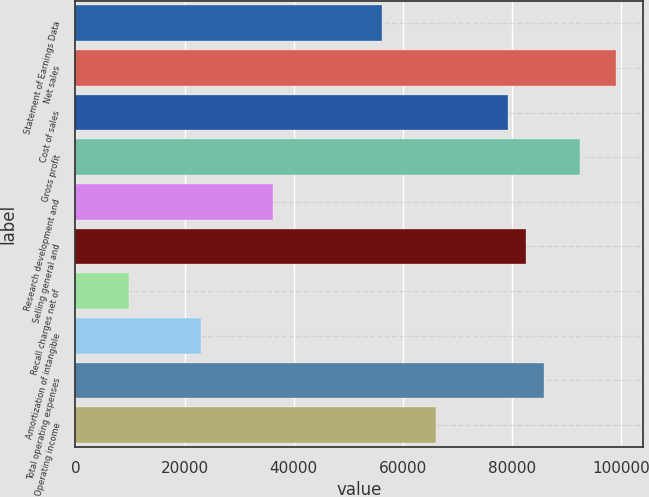Convert chart. <chart><loc_0><loc_0><loc_500><loc_500><bar_chart><fcel>Statement of Earnings Data<fcel>Net sales<fcel>Cost of sales<fcel>Gross profit<fcel>Research development and<fcel>Selling general and<fcel>Recall charges net of<fcel>Amortization of intangible<fcel>Total operating expenses<fcel>Operating income<nl><fcel>56098.8<fcel>98996.5<fcel>79197.5<fcel>92396.8<fcel>36299.9<fcel>82497.4<fcel>9901.24<fcel>23100.6<fcel>85797.2<fcel>65998.2<nl></chart> 